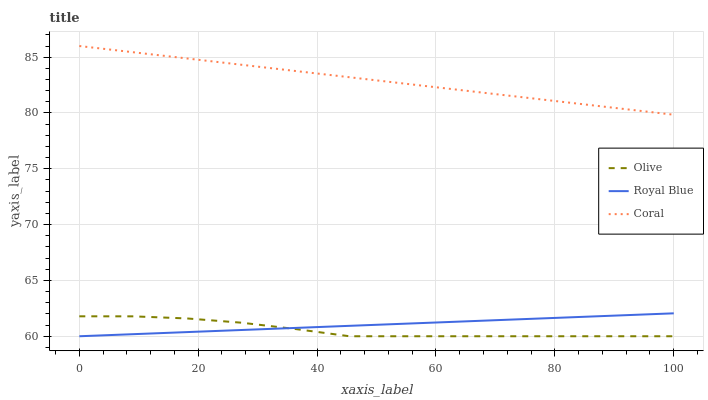Does Olive have the minimum area under the curve?
Answer yes or no. Yes. Does Coral have the maximum area under the curve?
Answer yes or no. Yes. Does Royal Blue have the minimum area under the curve?
Answer yes or no. No. Does Royal Blue have the maximum area under the curve?
Answer yes or no. No. Is Royal Blue the smoothest?
Answer yes or no. Yes. Is Olive the roughest?
Answer yes or no. Yes. Is Coral the smoothest?
Answer yes or no. No. Is Coral the roughest?
Answer yes or no. No. Does Olive have the lowest value?
Answer yes or no. Yes. Does Coral have the lowest value?
Answer yes or no. No. Does Coral have the highest value?
Answer yes or no. Yes. Does Royal Blue have the highest value?
Answer yes or no. No. Is Olive less than Coral?
Answer yes or no. Yes. Is Coral greater than Royal Blue?
Answer yes or no. Yes. Does Olive intersect Royal Blue?
Answer yes or no. Yes. Is Olive less than Royal Blue?
Answer yes or no. No. Is Olive greater than Royal Blue?
Answer yes or no. No. Does Olive intersect Coral?
Answer yes or no. No. 